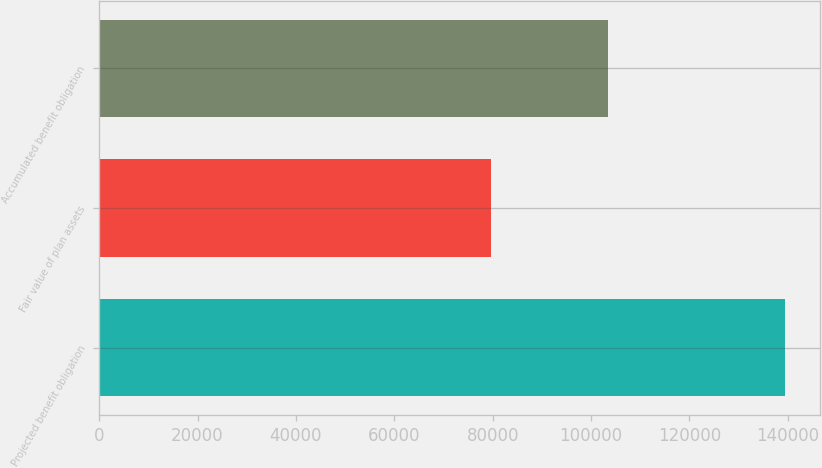Convert chart. <chart><loc_0><loc_0><loc_500><loc_500><bar_chart><fcel>Projected benefit obligation<fcel>Fair value of plan assets<fcel>Accumulated benefit obligation<nl><fcel>139516<fcel>79616<fcel>103470<nl></chart> 